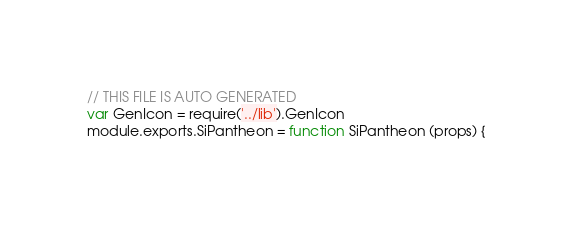Convert code to text. <code><loc_0><loc_0><loc_500><loc_500><_JavaScript_>// THIS FILE IS AUTO GENERATED
var GenIcon = require('../lib').GenIcon
module.exports.SiPantheon = function SiPantheon (props) {</code> 